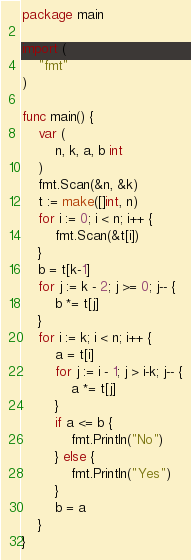Convert code to text. <code><loc_0><loc_0><loc_500><loc_500><_Go_>package main

import (
	"fmt"
)

func main() {
	var (
		n, k, a, b int
	)
	fmt.Scan(&n, &k)
	t := make([]int, n)
	for i := 0; i < n; i++ {
		fmt.Scan(&t[i])
	}
	b = t[k-1]
	for j := k - 2; j >= 0; j-- {
		b *= t[j]
	}
	for i := k; i < n; i++ {
		a = t[i]
		for j := i - 1; j > i-k; j-- {
			a *= t[j]
		}
		if a <= b {
			fmt.Println("No")
		} else {
			fmt.Println("Yes")
		}
		b = a
	}
}
</code> 